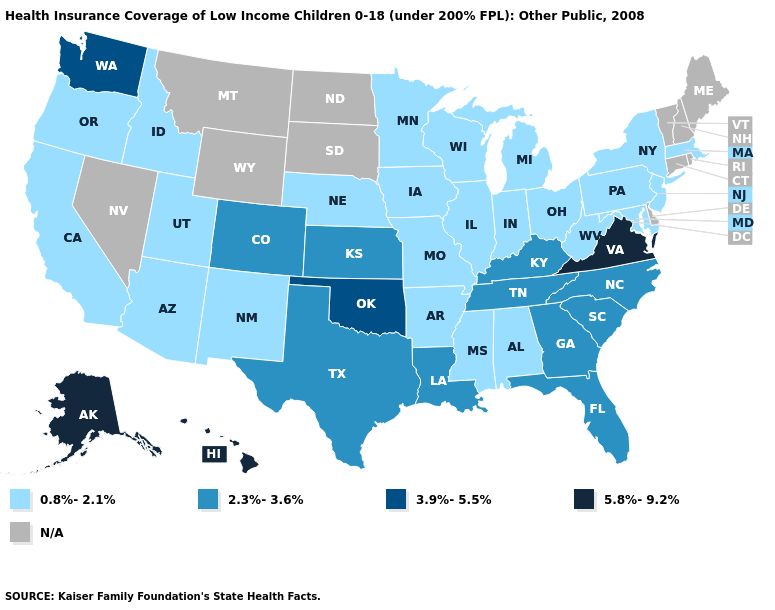Name the states that have a value in the range 2.3%-3.6%?
Be succinct. Colorado, Florida, Georgia, Kansas, Kentucky, Louisiana, North Carolina, South Carolina, Tennessee, Texas. What is the highest value in the West ?
Be succinct. 5.8%-9.2%. Name the states that have a value in the range 2.3%-3.6%?
Keep it brief. Colorado, Florida, Georgia, Kansas, Kentucky, Louisiana, North Carolina, South Carolina, Tennessee, Texas. Name the states that have a value in the range 5.8%-9.2%?
Concise answer only. Alaska, Hawaii, Virginia. What is the value of Rhode Island?
Keep it brief. N/A. What is the lowest value in the South?
Quick response, please. 0.8%-2.1%. How many symbols are there in the legend?
Keep it brief. 5. What is the lowest value in the USA?
Answer briefly. 0.8%-2.1%. Name the states that have a value in the range 5.8%-9.2%?
Write a very short answer. Alaska, Hawaii, Virginia. What is the value of Wisconsin?
Write a very short answer. 0.8%-2.1%. What is the value of Hawaii?
Quick response, please. 5.8%-9.2%. Name the states that have a value in the range 2.3%-3.6%?
Give a very brief answer. Colorado, Florida, Georgia, Kansas, Kentucky, Louisiana, North Carolina, South Carolina, Tennessee, Texas. 